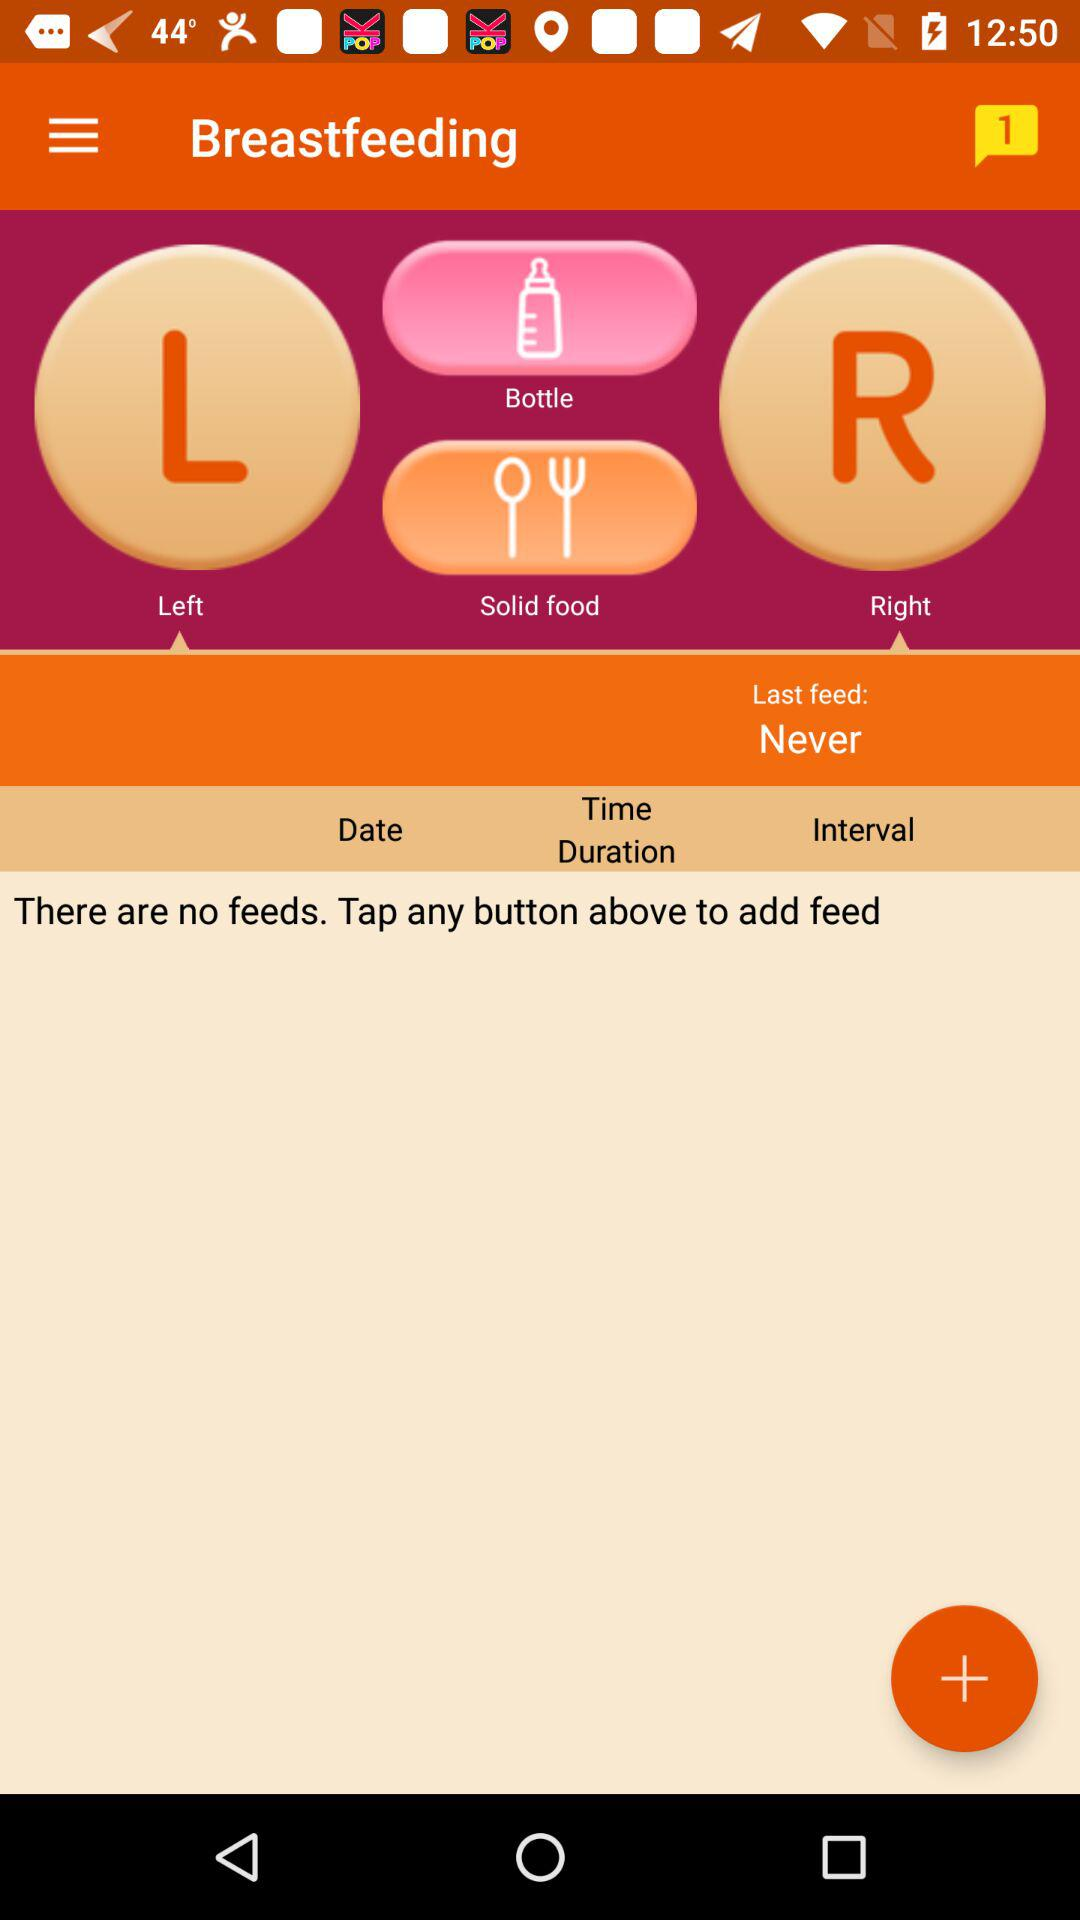How many unread notifications are there? There is 1 unread notification. 